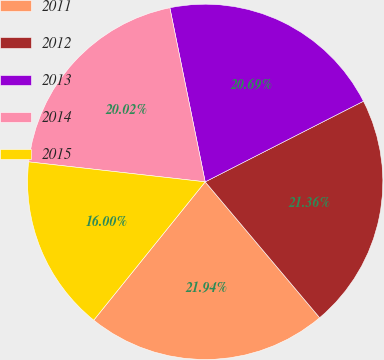Convert chart. <chart><loc_0><loc_0><loc_500><loc_500><pie_chart><fcel>2011<fcel>2012<fcel>2013<fcel>2014<fcel>2015<nl><fcel>21.94%<fcel>21.36%<fcel>20.69%<fcel>20.02%<fcel>16.0%<nl></chart> 